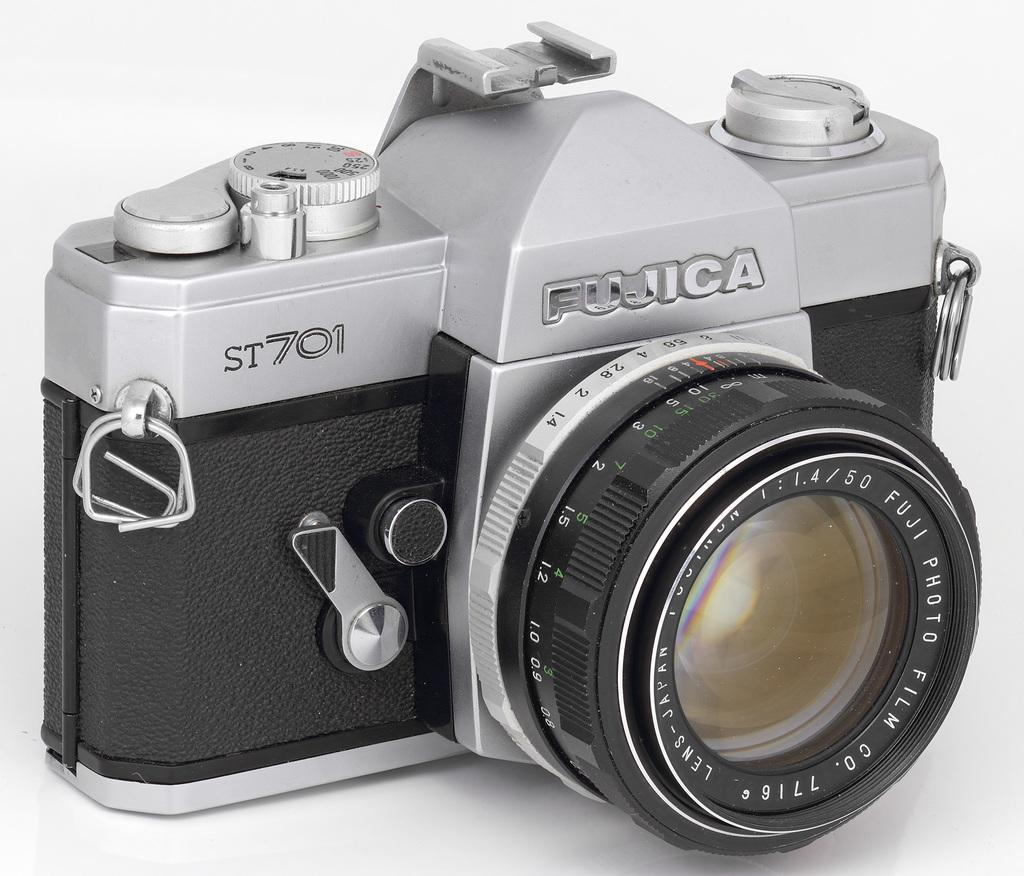<image>
Describe the image concisely. A Fujica camera also has a Fuji Film lens. 